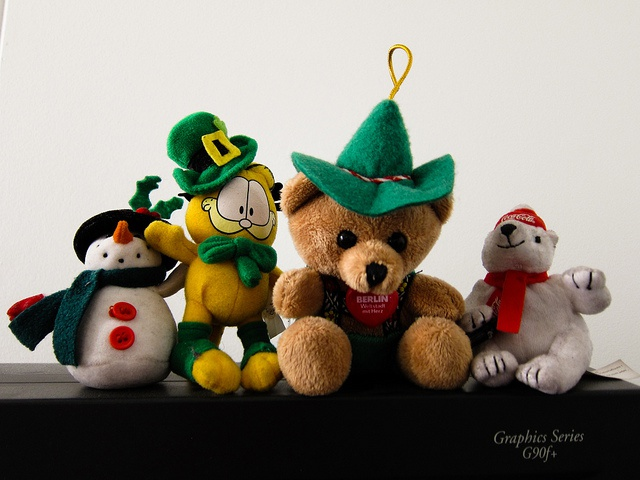Describe the objects in this image and their specific colors. I can see teddy bear in lightgray, black, maroon, and brown tones, teddy bear in lightgray, darkgray, gray, and maroon tones, tie in lightgray, black, darkgreen, and green tones, and tie in lightgray, maroon, and brown tones in this image. 